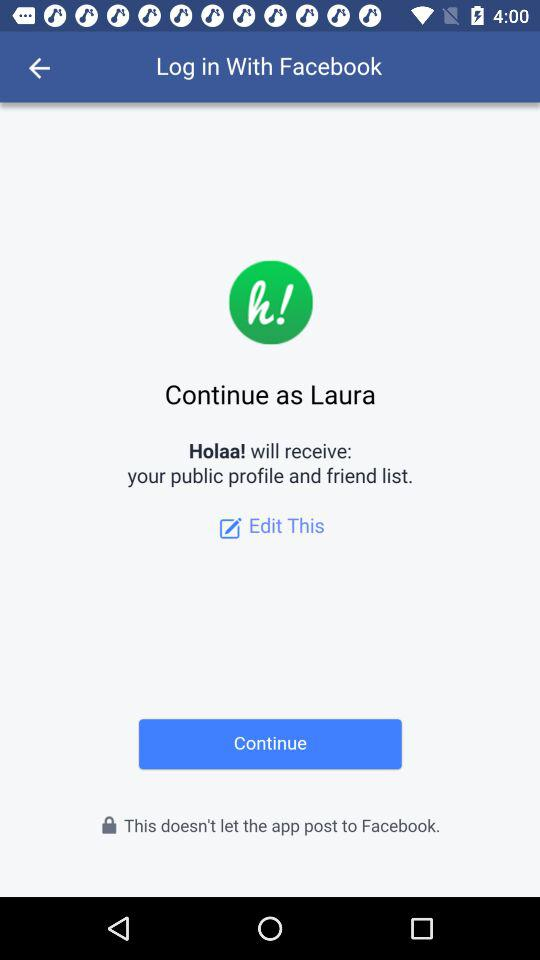What information can we edit? You can edit the profile picture and friend list. 